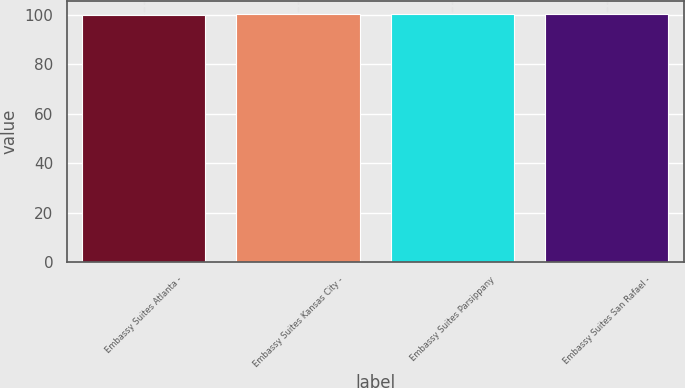<chart> <loc_0><loc_0><loc_500><loc_500><bar_chart><fcel>Embassy Suites Atlanta -<fcel>Embassy Suites Kansas City -<fcel>Embassy Suites Parsippany<fcel>Embassy Suites San Rafael -<nl><fcel>100<fcel>100.2<fcel>100.3<fcel>100.4<nl></chart> 